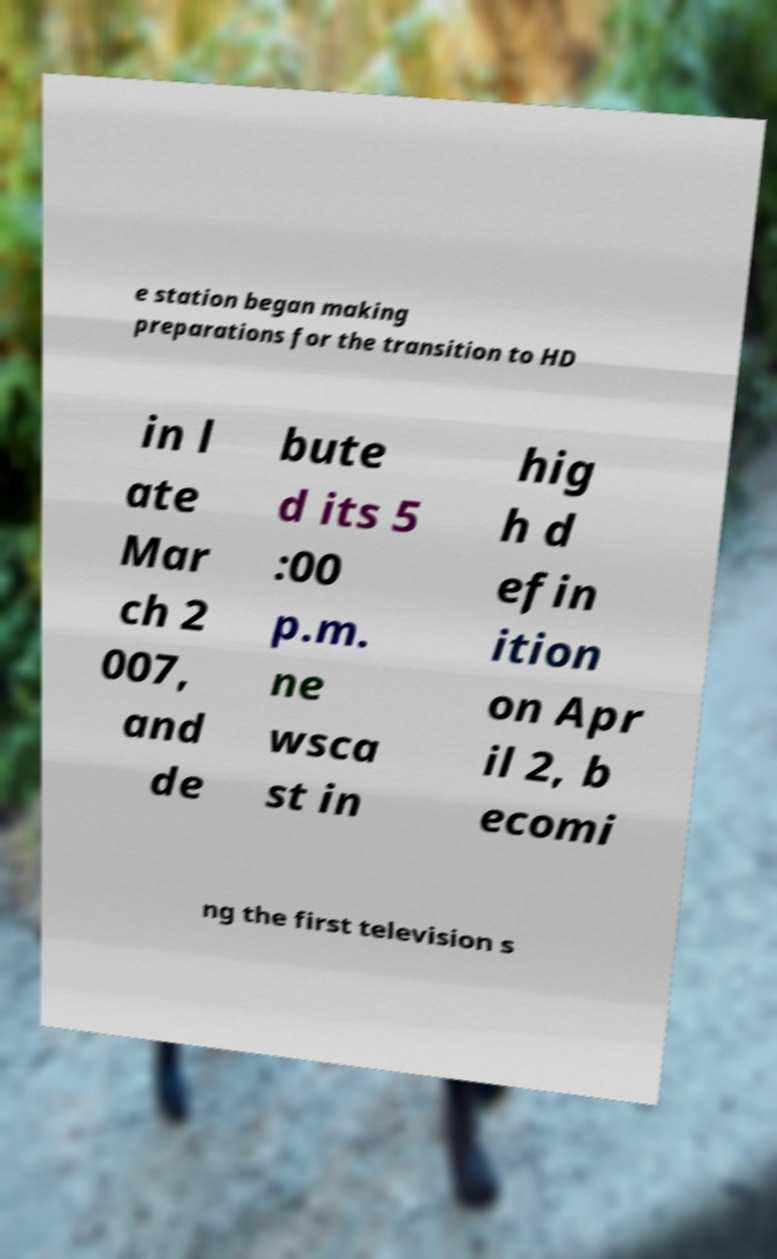Could you extract and type out the text from this image? e station began making preparations for the transition to HD in l ate Mar ch 2 007, and de bute d its 5 :00 p.m. ne wsca st in hig h d efin ition on Apr il 2, b ecomi ng the first television s 